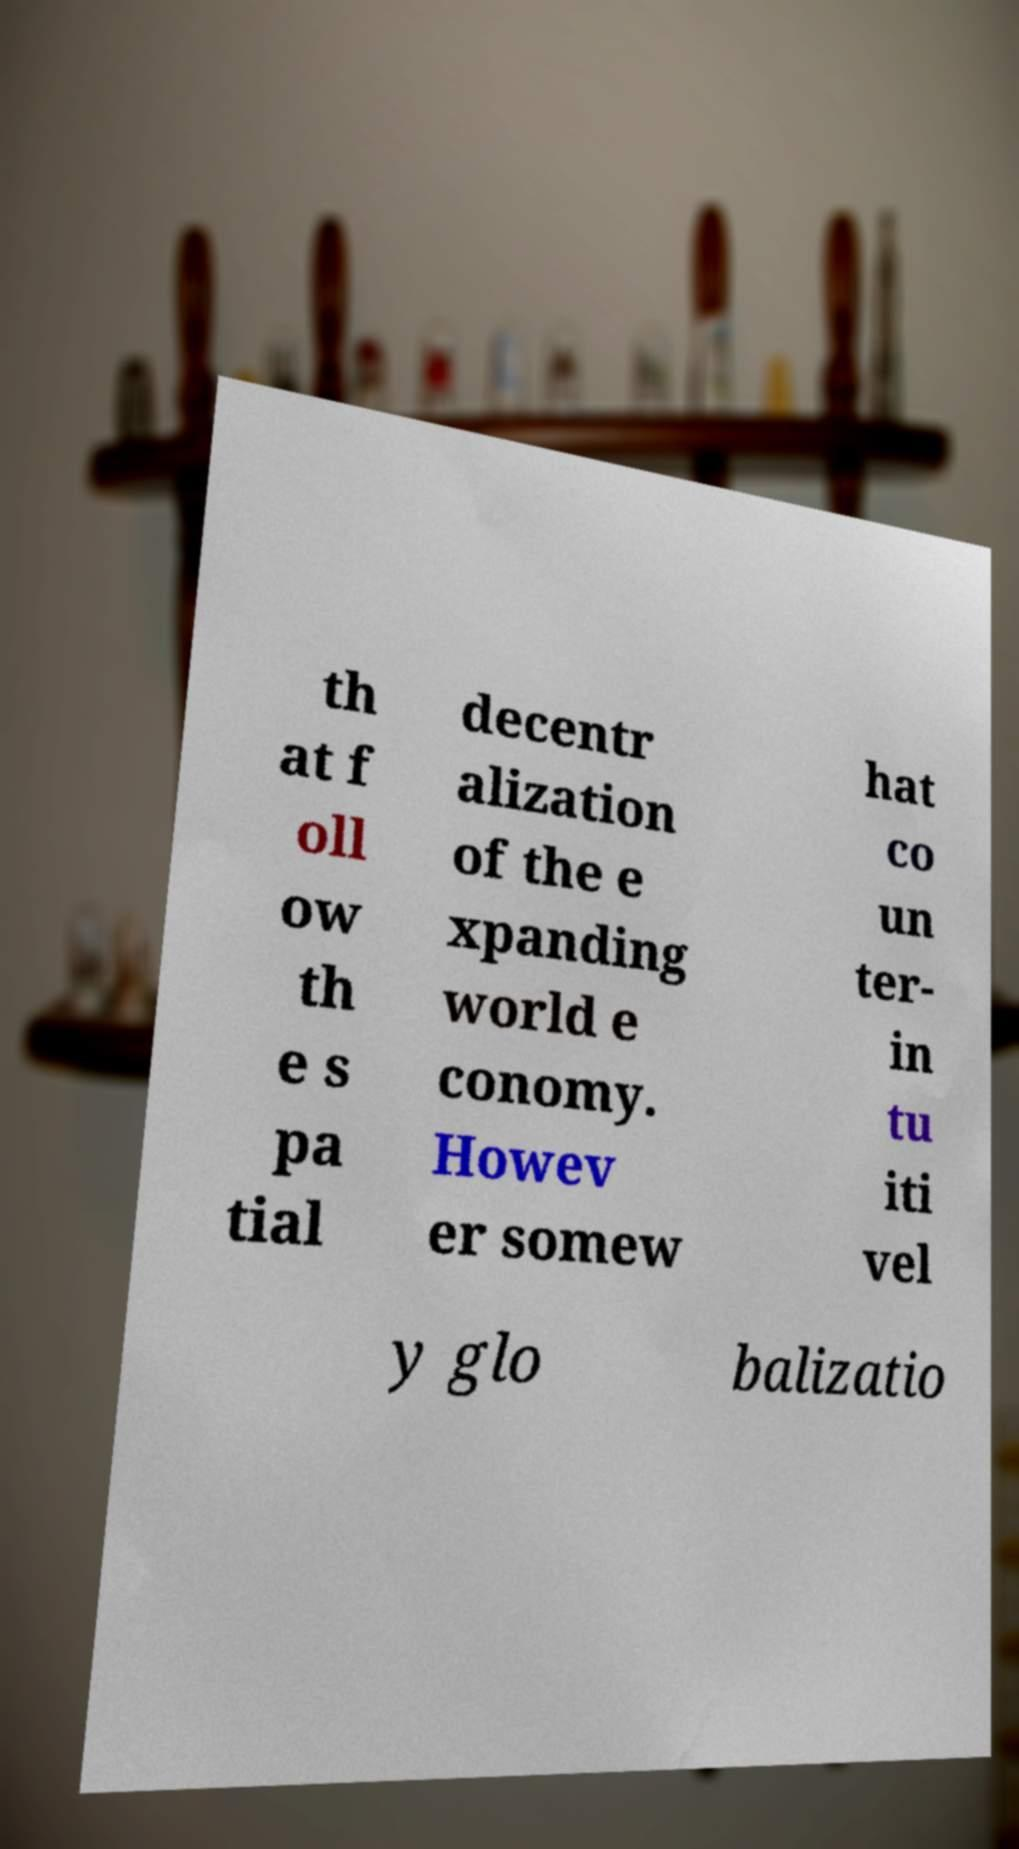Can you accurately transcribe the text from the provided image for me? th at f oll ow th e s pa tial decentr alization of the e xpanding world e conomy. Howev er somew hat co un ter- in tu iti vel y glo balizatio 